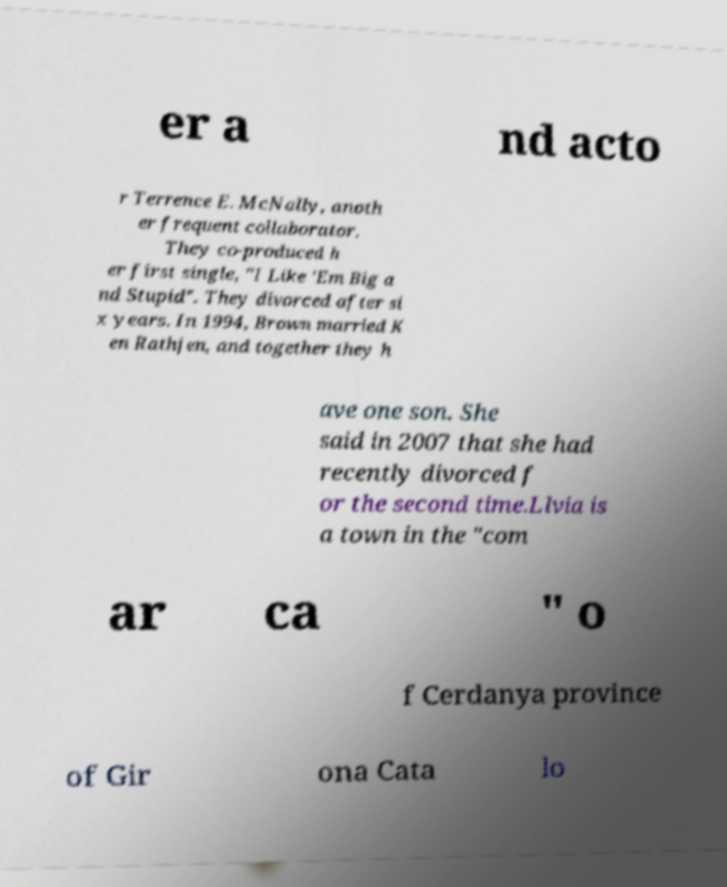There's text embedded in this image that I need extracted. Can you transcribe it verbatim? er a nd acto r Terrence E. McNally, anoth er frequent collaborator. They co-produced h er first single, "I Like 'Em Big a nd Stupid". They divorced after si x years. In 1994, Brown married K en Rathjen, and together they h ave one son. She said in 2007 that she had recently divorced f or the second time.Llvia is a town in the "com ar ca " o f Cerdanya province of Gir ona Cata lo 